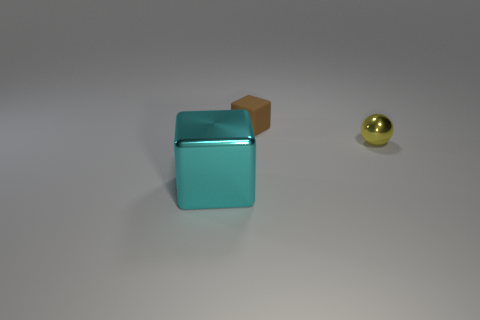Are there any other things that are the same material as the small brown block?
Your answer should be very brief. No. There is a cyan thing that is made of the same material as the yellow sphere; what shape is it?
Make the answer very short. Cube. What color is the shiny sphere that is the same size as the brown rubber object?
Keep it short and to the point. Yellow. Does the shiny thing that is on the right side of the cyan object have the same size as the cyan block?
Ensure brevity in your answer.  No. Do the tiny sphere and the small block have the same color?
Your answer should be compact. No. How many brown blocks are there?
Make the answer very short. 1. How many cubes are either large blue metal things or large metal objects?
Ensure brevity in your answer.  1. There is a small thing that is in front of the tiny brown block; what number of cyan metallic cubes are left of it?
Your answer should be compact. 1. Are the small cube and the big cyan block made of the same material?
Provide a short and direct response. No. Is there a big cyan block that has the same material as the cyan thing?
Your answer should be compact. No. 